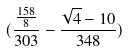<formula> <loc_0><loc_0><loc_500><loc_500>( \frac { \frac { 1 5 8 } { 8 } } { 3 0 3 } - \frac { \sqrt { 4 } - 1 0 } { 3 4 8 } )</formula> 